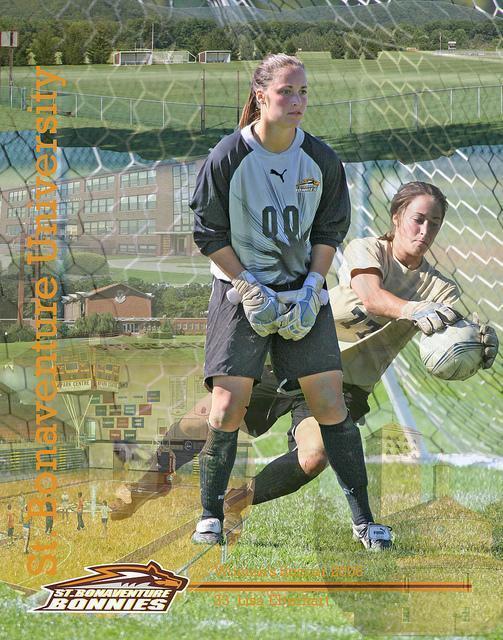How many sports balls are there?
Give a very brief answer. 1. How many people can be seen?
Give a very brief answer. 2. How many blue cars are there?
Give a very brief answer. 0. 